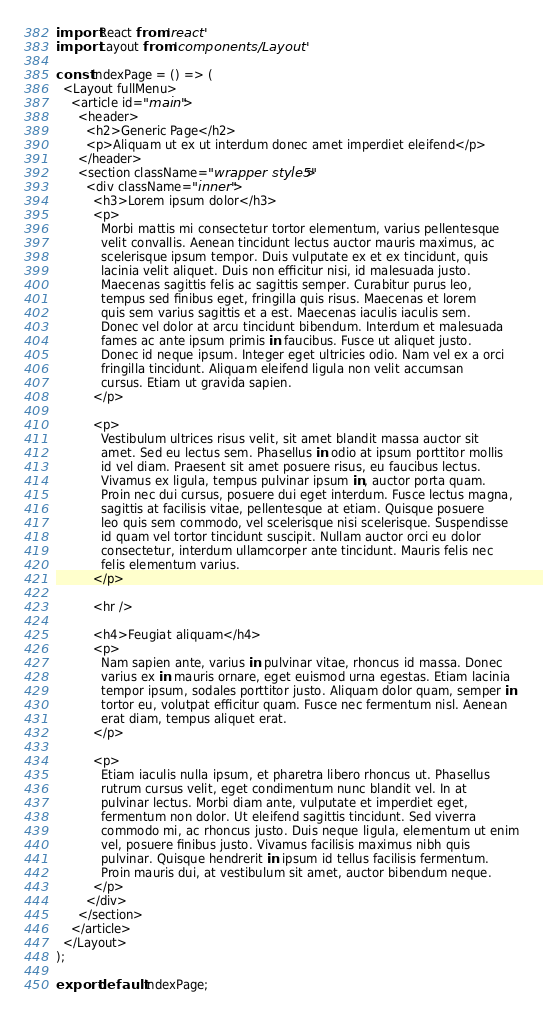<code> <loc_0><loc_0><loc_500><loc_500><_JavaScript_>import React from 'react'
import Layout from 'components/Layout'

const IndexPage = () => (
  <Layout fullMenu>
    <article id="main">
      <header>
        <h2>Generic Page</h2>
        <p>Aliquam ut ex ut interdum donec amet imperdiet eleifend</p>
      </header>
      <section className="wrapper style5">
        <div className="inner">
          <h3>Lorem ipsum dolor</h3>
          <p>
            Morbi mattis mi consectetur tortor elementum, varius pellentesque
            velit convallis. Aenean tincidunt lectus auctor mauris maximus, ac
            scelerisque ipsum tempor. Duis vulputate ex et ex tincidunt, quis
            lacinia velit aliquet. Duis non efficitur nisi, id malesuada justo.
            Maecenas sagittis felis ac sagittis semper. Curabitur purus leo,
            tempus sed finibus eget, fringilla quis risus. Maecenas et lorem
            quis sem varius sagittis et a est. Maecenas iaculis iaculis sem.
            Donec vel dolor at arcu tincidunt bibendum. Interdum et malesuada
            fames ac ante ipsum primis in faucibus. Fusce ut aliquet justo.
            Donec id neque ipsum. Integer eget ultricies odio. Nam vel ex a orci
            fringilla tincidunt. Aliquam eleifend ligula non velit accumsan
            cursus. Etiam ut gravida sapien.
          </p>

          <p>
            Vestibulum ultrices risus velit, sit amet blandit massa auctor sit
            amet. Sed eu lectus sem. Phasellus in odio at ipsum porttitor mollis
            id vel diam. Praesent sit amet posuere risus, eu faucibus lectus.
            Vivamus ex ligula, tempus pulvinar ipsum in, auctor porta quam.
            Proin nec dui cursus, posuere dui eget interdum. Fusce lectus magna,
            sagittis at facilisis vitae, pellentesque at etiam. Quisque posuere
            leo quis sem commodo, vel scelerisque nisi scelerisque. Suspendisse
            id quam vel tortor tincidunt suscipit. Nullam auctor orci eu dolor
            consectetur, interdum ullamcorper ante tincidunt. Mauris felis nec
            felis elementum varius.
          </p>

          <hr />

          <h4>Feugiat aliquam</h4>
          <p>
            Nam sapien ante, varius in pulvinar vitae, rhoncus id massa. Donec
            varius ex in mauris ornare, eget euismod urna egestas. Etiam lacinia
            tempor ipsum, sodales porttitor justo. Aliquam dolor quam, semper in
            tortor eu, volutpat efficitur quam. Fusce nec fermentum nisl. Aenean
            erat diam, tempus aliquet erat.
          </p>

          <p>
            Etiam iaculis nulla ipsum, et pharetra libero rhoncus ut. Phasellus
            rutrum cursus velit, eget condimentum nunc blandit vel. In at
            pulvinar lectus. Morbi diam ante, vulputate et imperdiet eget,
            fermentum non dolor. Ut eleifend sagittis tincidunt. Sed viverra
            commodo mi, ac rhoncus justo. Duis neque ligula, elementum ut enim
            vel, posuere finibus justo. Vivamus facilisis maximus nibh quis
            pulvinar. Quisque hendrerit in ipsum id tellus facilisis fermentum.
            Proin mauris dui, at vestibulum sit amet, auctor bibendum neque.
          </p>
        </div>
      </section>
    </article>
  </Layout>
);

export default IndexPage;
</code> 